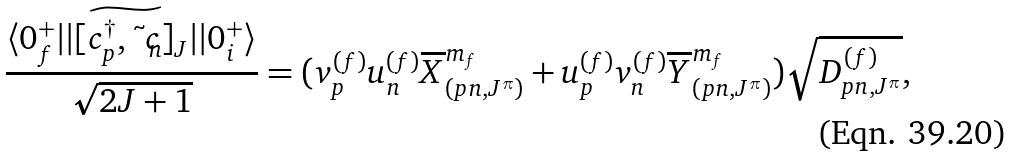<formula> <loc_0><loc_0><loc_500><loc_500>\frac { \langle 0 ^ { + } _ { f } | | [ \widetilde { c _ { p } ^ { \dagger } , { \tilde { c } } _ { n } } ] _ { J } | | 0 ^ { + } _ { i } \rangle } { \sqrt { 2 J + 1 } } = ( v _ { p } ^ { ( f ) } u _ { n } ^ { ( f ) } \overline { X } _ { ( p n , J ^ { \pi } ) } ^ { m _ { f } } + u _ { p } ^ { ( f ) } v _ { n } ^ { ( f ) } \overline { Y } _ { ( p n , J ^ { \pi } ) } ^ { m _ { f } } ) \sqrt { D _ { p n , J ^ { \pi } } ^ { ( f ) } } ,</formula> 